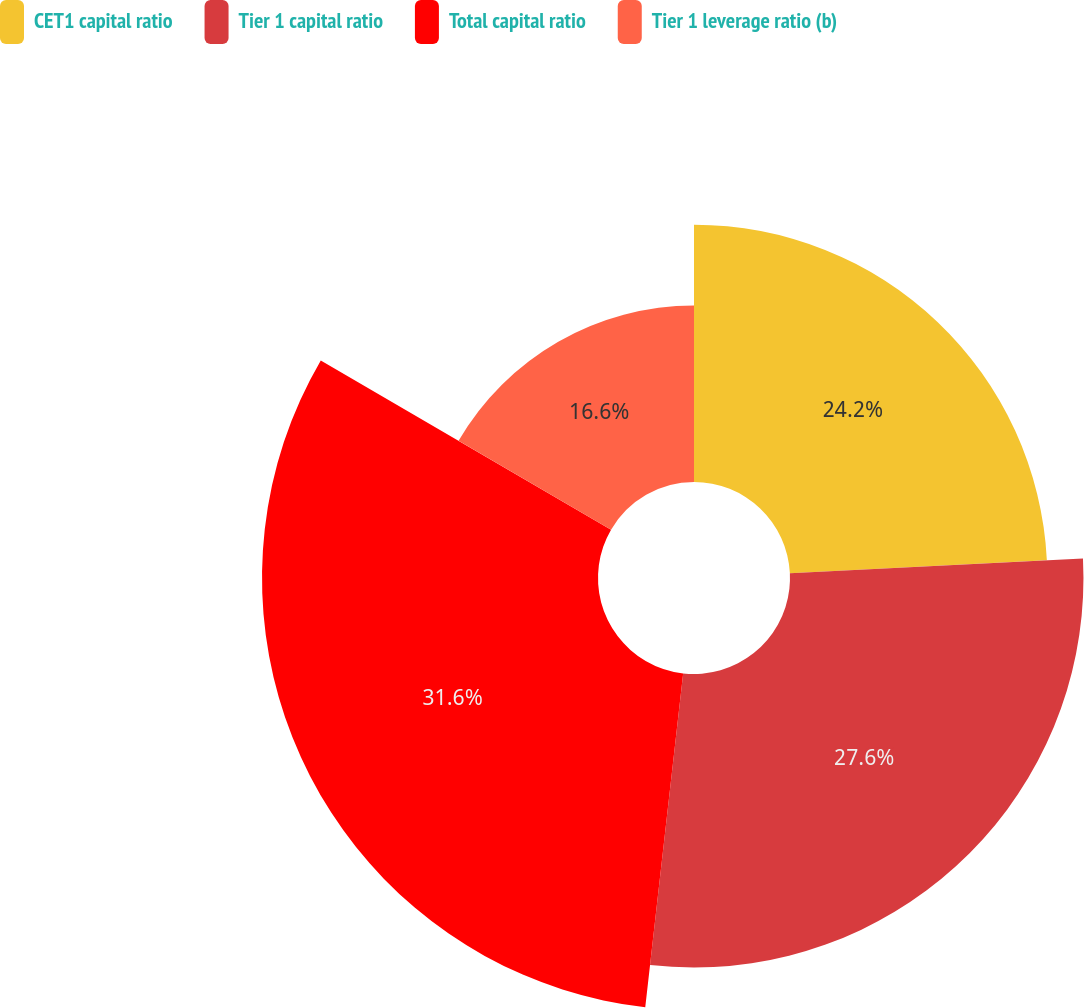Convert chart. <chart><loc_0><loc_0><loc_500><loc_500><pie_chart><fcel>CET1 capital ratio<fcel>Tier 1 capital ratio<fcel>Total capital ratio<fcel>Tier 1 leverage ratio (b)<nl><fcel>24.2%<fcel>27.6%<fcel>31.6%<fcel>16.6%<nl></chart> 